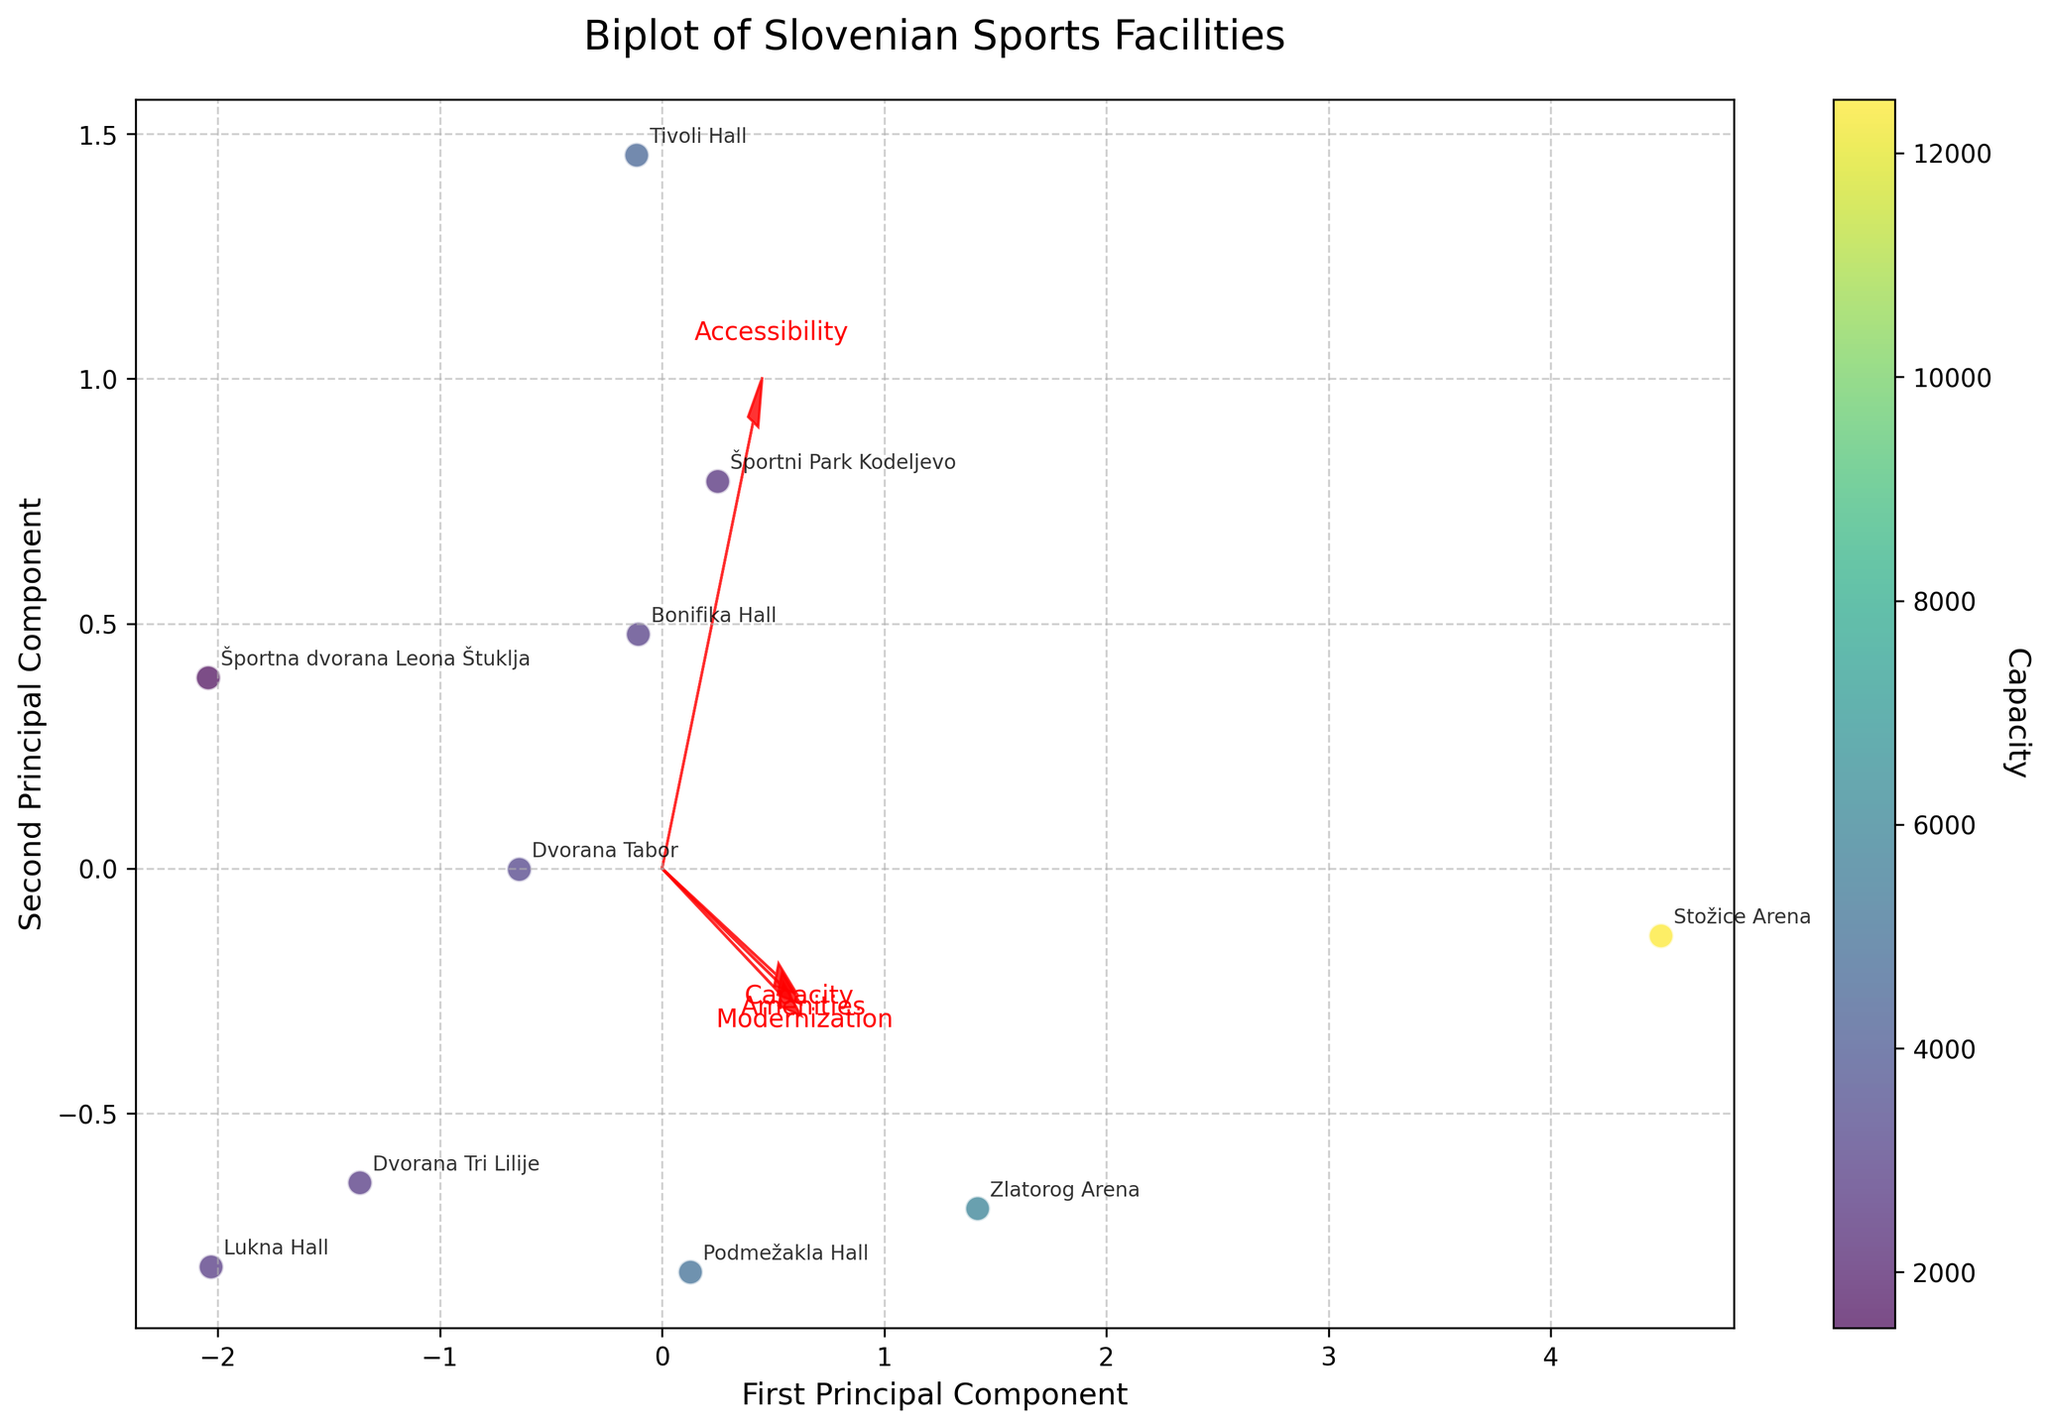How many sports facilities are shown in the figure? Count the number of distinct data points (each representing a facility) on the plot.
Answer: 10 What factors are represented by the red arrows in the biplot? The red arrows represent the features "Capacity," "Amenities," "Accessibility," and "Modernization."
Answer: Capacity, Amenities, Accessibility, Modernization Which facility has the highest capacity? The color bar indicates capacity, and the point with the darkest shade (highest value) on the color gradient is the facility with the highest capacity.
Answer: Stožice Arena How does "Amenities" align with the first and second principal components? Look at the direction and length of the arrow labeled "Amenities"; it's closely aligned with both the first and second principal components, indicating strong contributions from both components.
Answer: Strongly with both Which two facilities are most similar when projected onto the first two principal components? Points that are closest to each other on the plot represent the most similar facilities. Check the distance between pairs of points.
Answer: Tivoli Hall and Športni Park Kodeljevo Which feature has the smallest influence on the first principal component? Examine the length of the arrows along the direction of the first principal component. The shortest arrow contributes the least.
Answer: Modernization How do facilities in Ljubljana cluster together in the biplot? Identify and compare the relative positions of the points labeled "Stožice Arena," "Tivoli Hall," and "Športni Park Kodeljevo" on the plot.
Answer: They cluster somewhat closely but not in the same exact spot Between "Dvorana Tabor" and "Lukna Hall," which one scores higher for "Amenities"? Compare the positions of the two facilities relative to the "Amenities" vector (arrow); the point further in the direction of the arrow scores higher.
Answer: Dvorana Tabor What can be inferred about the relationship between "Capacity" and the first principal component? Observe the orientation of the "Capacity" vector relative to the first principal component axis; a strong alignment suggests a positive relationship.
Answer: Positive Are there any facilities with high modernization but low amenities scores? Check the vectors for "Modernization" and "Amenities" and identify if any facility is closely aligned with "Modernization" but far from "Amenities."
Answer: No 